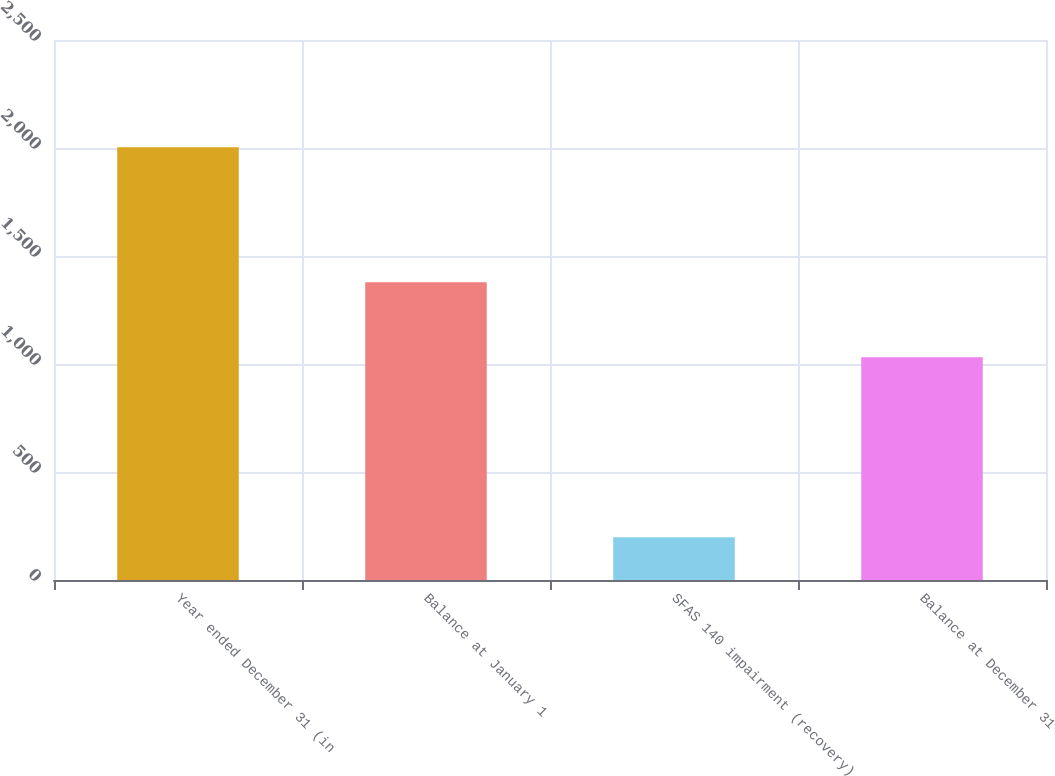<chart> <loc_0><loc_0><loc_500><loc_500><bar_chart><fcel>Year ended December 31 (in<fcel>Balance at January 1<fcel>SFAS 140 impairment (recovery)<fcel>Balance at December 31<nl><fcel>2004<fcel>1378<fcel>198<fcel>1031<nl></chart> 